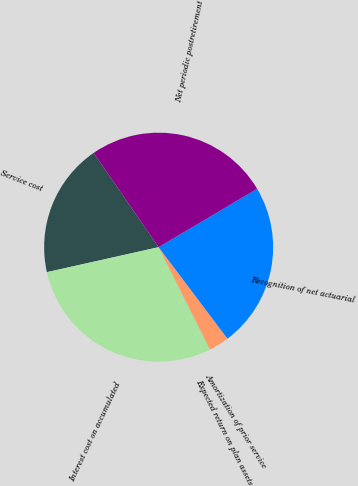Convert chart to OTSL. <chart><loc_0><loc_0><loc_500><loc_500><pie_chart><fcel>Service cost<fcel>Interest cost on accumulated<fcel>Expected return on plan assets<fcel>Amortization of prior service<fcel>Recognition of net actuarial<fcel>Net periodic postretirement<nl><fcel>18.9%<fcel>28.92%<fcel>0.01%<fcel>2.84%<fcel>23.25%<fcel>26.09%<nl></chart> 